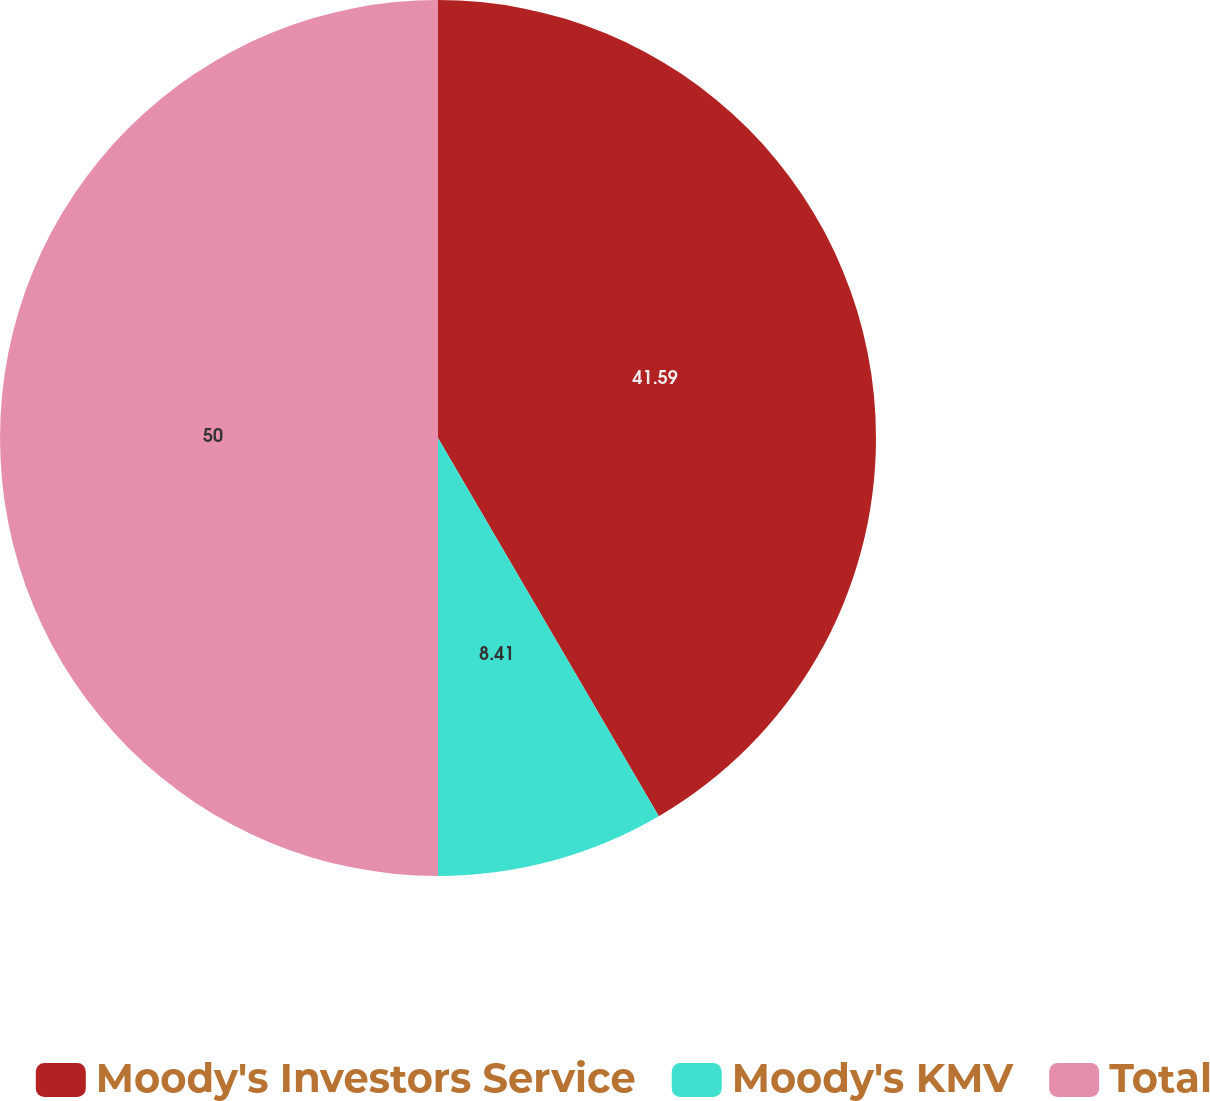Convert chart to OTSL. <chart><loc_0><loc_0><loc_500><loc_500><pie_chart><fcel>Moody's Investors Service<fcel>Moody's KMV<fcel>Total<nl><fcel>41.59%<fcel>8.41%<fcel>50.0%<nl></chart> 